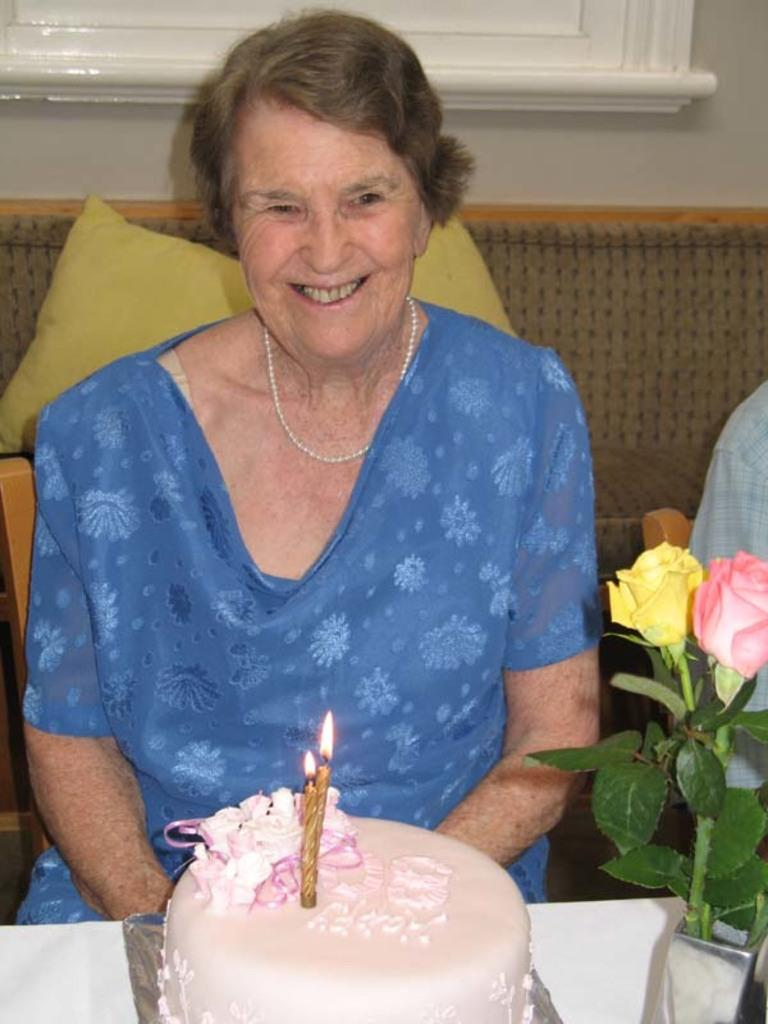What is the person in the image doing? The person is sitting on a chair in the image. What can be seen in the background of the image? There is a sofa and a wall in the background of the image. What is on the table in the image? There is a cake and a flower on the table in the image. What is on the sofa in the image? There are pillows on the sofa in the image. What type of nail is being used to hold the cake together in the image? There is no nail present in the image, and the cake does not require any nails to hold it together. 